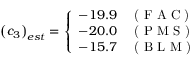Convert formula to latex. <formula><loc_0><loc_0><loc_500><loc_500>\left ( c _ { 3 } \right ) _ { e s t } = \left \{ \begin{array} { l l } { - 1 9 . 9 } & { ( F A C ) } \\ { - 2 0 . 0 } & { ( P M S ) } \\ { - 1 5 . 7 } & { ( B L M ) } \end{array}</formula> 